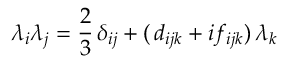<formula> <loc_0><loc_0><loc_500><loc_500>\lambda _ { i } \lambda _ { j } = \frac { 2 } { 3 } \, \delta _ { i j } + ( \, d _ { i j k } + i f _ { i j k } ) \, \lambda _ { k }</formula> 